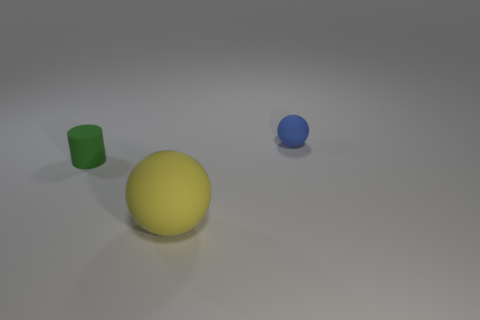Is there any other thing that has the same size as the yellow matte thing?
Offer a very short reply. No. What color is the matte cylinder?
Make the answer very short. Green. Is there a small rubber thing of the same color as the cylinder?
Offer a very short reply. No. Is the color of the matte sphere to the right of the large rubber sphere the same as the cylinder?
Provide a short and direct response. No. What number of things are small matte things left of the blue thing or large blue objects?
Offer a very short reply. 1. There is a tiny green rubber cylinder; are there any objects on the right side of it?
Offer a very short reply. Yes. Is the material of the object that is to the right of the large thing the same as the green object?
Provide a succinct answer. Yes. Is there a tiny blue object that is in front of the green thing behind the ball in front of the blue ball?
Keep it short and to the point. No. How many cylinders are small blue rubber objects or yellow objects?
Your response must be concise. 0. What is the material of the sphere that is to the right of the large ball?
Make the answer very short. Rubber. 